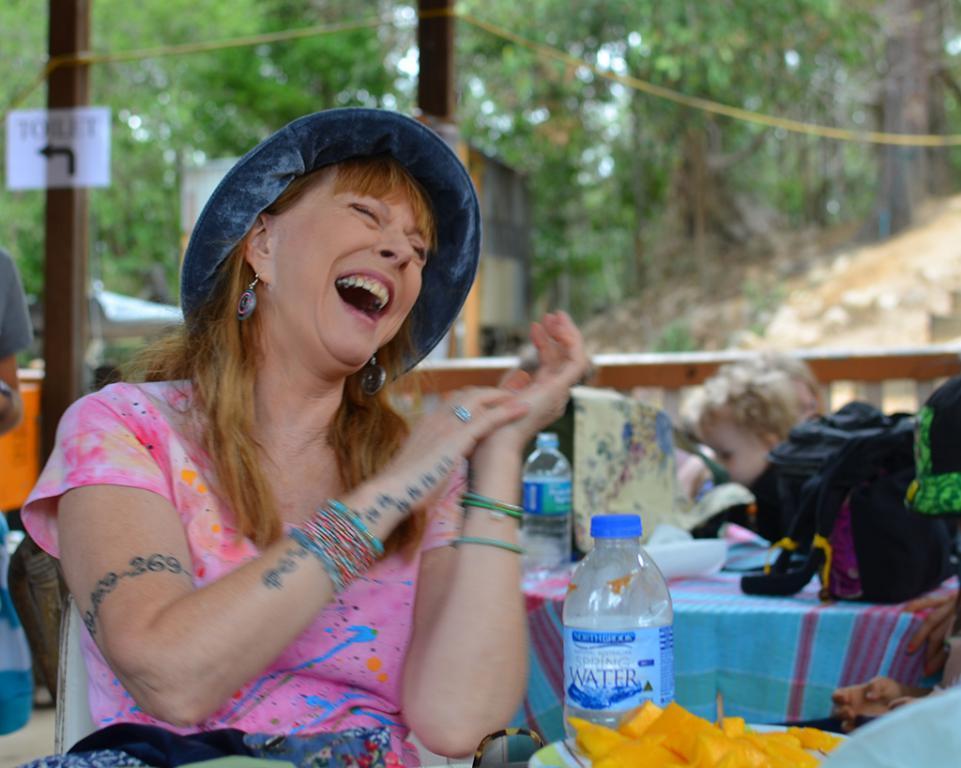Could you give a brief overview of what you see in this image? In the picture we can see a woman sitting near the table and laughing and on the table, we can see a plate with fruit salads and a water bottle and behind it, we can see some table and near it, we can see a person sitting and behind the person we can see a railing and from it we can see many trees. 